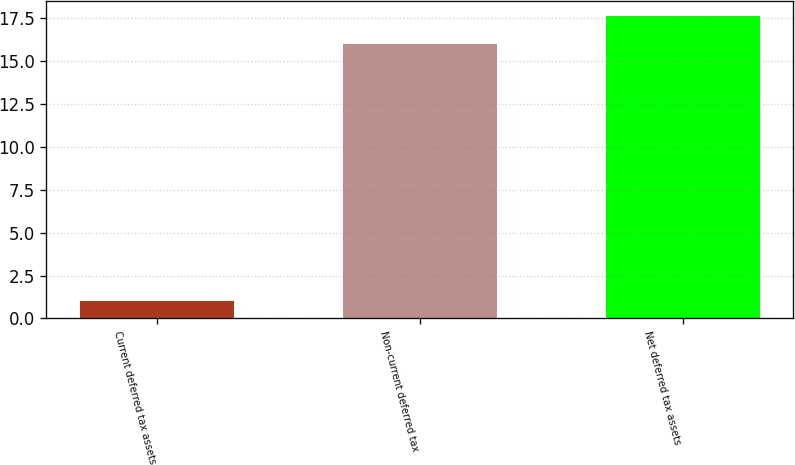<chart> <loc_0><loc_0><loc_500><loc_500><bar_chart><fcel>Current deferred tax assets<fcel>Non-current deferred tax<fcel>Net deferred tax assets<nl><fcel>1<fcel>16<fcel>17.6<nl></chart> 